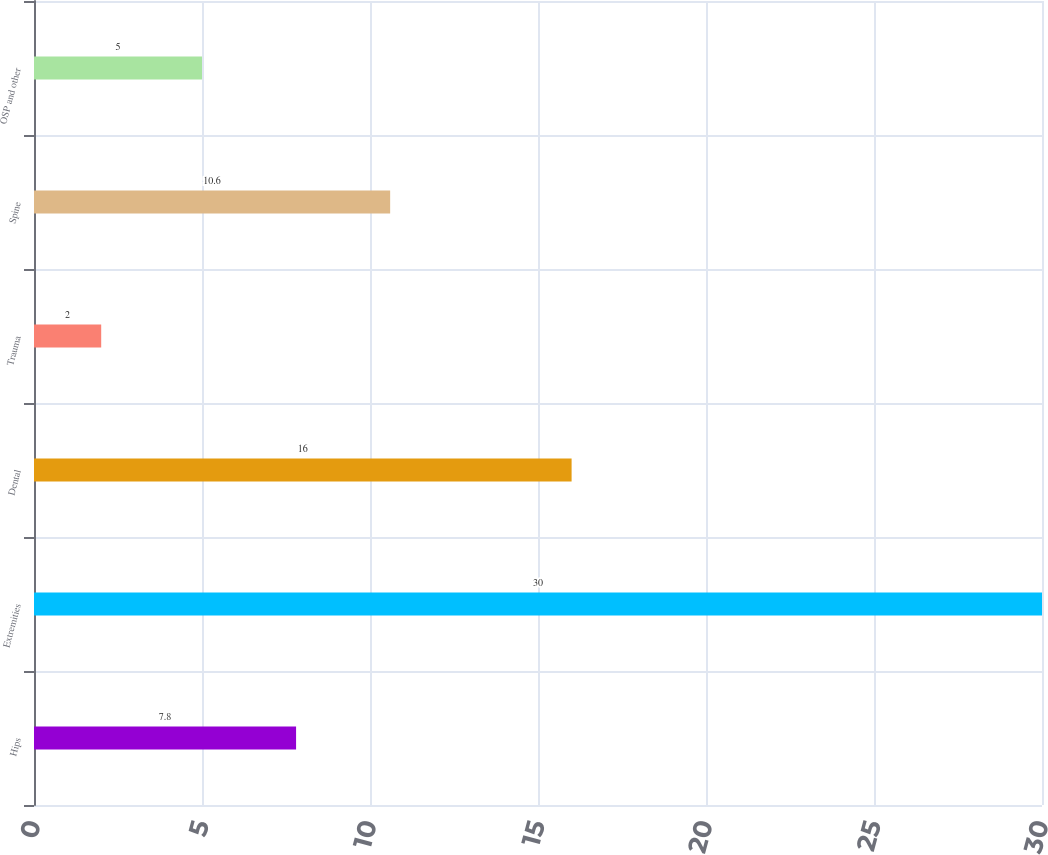Convert chart. <chart><loc_0><loc_0><loc_500><loc_500><bar_chart><fcel>Hips<fcel>Extremities<fcel>Dental<fcel>Trauma<fcel>Spine<fcel>OSP and other<nl><fcel>7.8<fcel>30<fcel>16<fcel>2<fcel>10.6<fcel>5<nl></chart> 